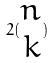<formula> <loc_0><loc_0><loc_500><loc_500>2 ( \begin{matrix} n \\ k \end{matrix} )</formula> 